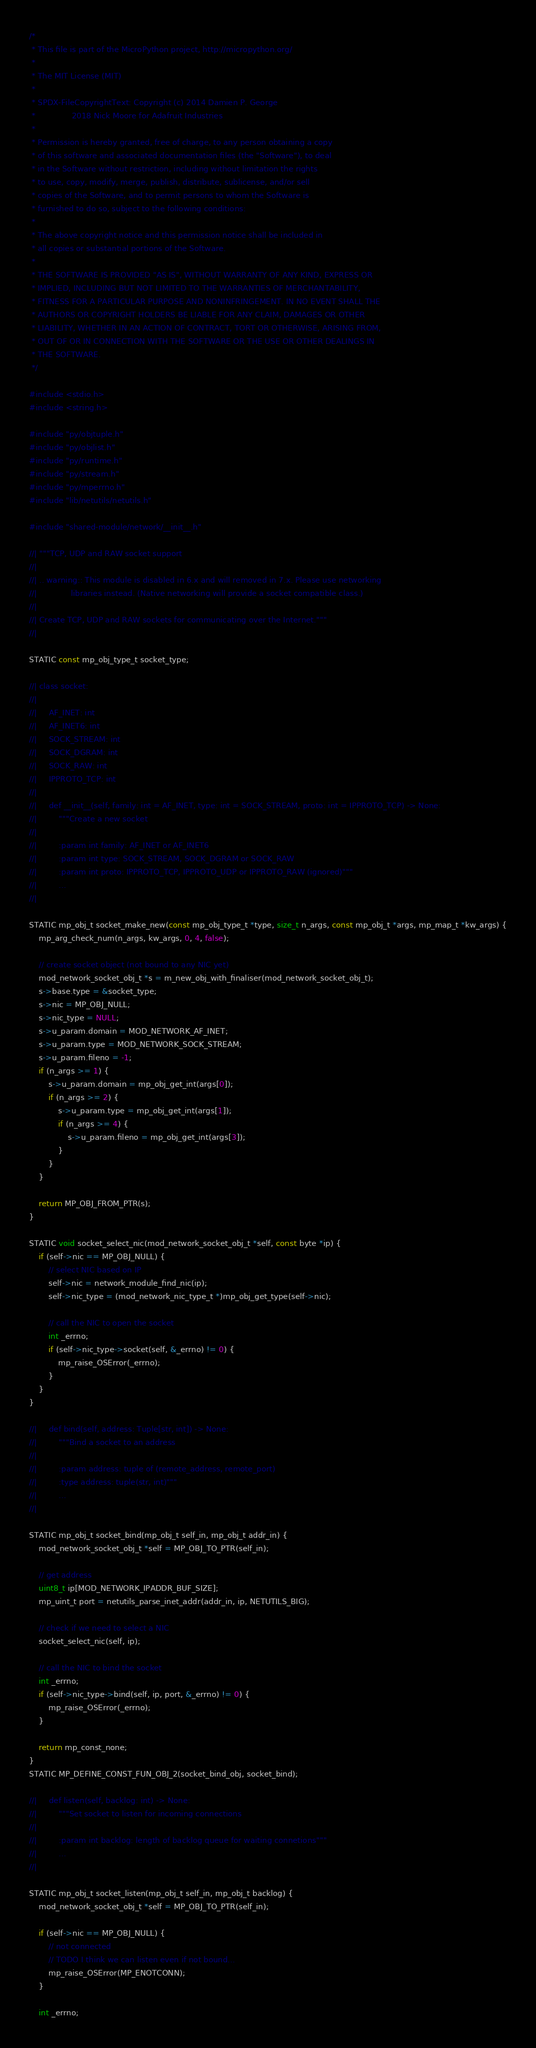Convert code to text. <code><loc_0><loc_0><loc_500><loc_500><_C_>/*
 * This file is part of the MicroPython project, http://micropython.org/
 *
 * The MIT License (MIT)
 *
 * SPDX-FileCopyrightText: Copyright (c) 2014 Damien P. George
 *               2018 Nick Moore for Adafruit Industries
 *
 * Permission is hereby granted, free of charge, to any person obtaining a copy
 * of this software and associated documentation files (the "Software"), to deal
 * in the Software without restriction, including without limitation the rights
 * to use, copy, modify, merge, publish, distribute, sublicense, and/or sell
 * copies of the Software, and to permit persons to whom the Software is
 * furnished to do so, subject to the following conditions:
 *
 * The above copyright notice and this permission notice shall be included in
 * all copies or substantial portions of the Software.
 *
 * THE SOFTWARE IS PROVIDED "AS IS", WITHOUT WARRANTY OF ANY KIND, EXPRESS OR
 * IMPLIED, INCLUDING BUT NOT LIMITED TO THE WARRANTIES OF MERCHANTABILITY,
 * FITNESS FOR A PARTICULAR PURPOSE AND NONINFRINGEMENT. IN NO EVENT SHALL THE
 * AUTHORS OR COPYRIGHT HOLDERS BE LIABLE FOR ANY CLAIM, DAMAGES OR OTHER
 * LIABILITY, WHETHER IN AN ACTION OF CONTRACT, TORT OR OTHERWISE, ARISING FROM,
 * OUT OF OR IN CONNECTION WITH THE SOFTWARE OR THE USE OR OTHER DEALINGS IN
 * THE SOFTWARE.
 */

#include <stdio.h>
#include <string.h>

#include "py/objtuple.h"
#include "py/objlist.h"
#include "py/runtime.h"
#include "py/stream.h"
#include "py/mperrno.h"
#include "lib/netutils/netutils.h"

#include "shared-module/network/__init__.h"

//| """TCP, UDP and RAW socket support
//|
//| .. warning:: This module is disabled in 6.x and will removed in 7.x. Please use networking
//|              libraries instead. (Native networking will provide a socket compatible class.)
//|
//| Create TCP, UDP and RAW sockets for communicating over the Internet."""
//|

STATIC const mp_obj_type_t socket_type;

//| class socket:
//|
//|     AF_INET: int
//|     AF_INET6: int
//|     SOCK_STREAM: int
//|     SOCK_DGRAM: int
//|     SOCK_RAW: int
//|     IPPROTO_TCP: int
//|
//|     def __init__(self, family: int = AF_INET, type: int = SOCK_STREAM, proto: int = IPPROTO_TCP) -> None:
//|         """Create a new socket
//|
//|         :param int family: AF_INET or AF_INET6
//|         :param int type: SOCK_STREAM, SOCK_DGRAM or SOCK_RAW
//|         :param int proto: IPPROTO_TCP, IPPROTO_UDP or IPPROTO_RAW (ignored)"""
//|         ...
//|

STATIC mp_obj_t socket_make_new(const mp_obj_type_t *type, size_t n_args, const mp_obj_t *args, mp_map_t *kw_args) {
    mp_arg_check_num(n_args, kw_args, 0, 4, false);

    // create socket object (not bound to any NIC yet)
    mod_network_socket_obj_t *s = m_new_obj_with_finaliser(mod_network_socket_obj_t);
    s->base.type = &socket_type;
    s->nic = MP_OBJ_NULL;
    s->nic_type = NULL;
    s->u_param.domain = MOD_NETWORK_AF_INET;
    s->u_param.type = MOD_NETWORK_SOCK_STREAM;
    s->u_param.fileno = -1;
    if (n_args >= 1) {
        s->u_param.domain = mp_obj_get_int(args[0]);
        if (n_args >= 2) {
            s->u_param.type = mp_obj_get_int(args[1]);
            if (n_args >= 4) {
                s->u_param.fileno = mp_obj_get_int(args[3]);
            }
        }
    }

    return MP_OBJ_FROM_PTR(s);
}

STATIC void socket_select_nic(mod_network_socket_obj_t *self, const byte *ip) {
    if (self->nic == MP_OBJ_NULL) {
        // select NIC based on IP
        self->nic = network_module_find_nic(ip);
        self->nic_type = (mod_network_nic_type_t *)mp_obj_get_type(self->nic);

        // call the NIC to open the socket
        int _errno;
        if (self->nic_type->socket(self, &_errno) != 0) {
            mp_raise_OSError(_errno);
        }
    }
}

//|     def bind(self, address: Tuple[str, int]) -> None:
//|         """Bind a socket to an address
//|
//|         :param address: tuple of (remote_address, remote_port)
//|         :type address: tuple(str, int)"""
//|         ...
//|

STATIC mp_obj_t socket_bind(mp_obj_t self_in, mp_obj_t addr_in) {
    mod_network_socket_obj_t *self = MP_OBJ_TO_PTR(self_in);

    // get address
    uint8_t ip[MOD_NETWORK_IPADDR_BUF_SIZE];
    mp_uint_t port = netutils_parse_inet_addr(addr_in, ip, NETUTILS_BIG);

    // check if we need to select a NIC
    socket_select_nic(self, ip);

    // call the NIC to bind the socket
    int _errno;
    if (self->nic_type->bind(self, ip, port, &_errno) != 0) {
        mp_raise_OSError(_errno);
    }

    return mp_const_none;
}
STATIC MP_DEFINE_CONST_FUN_OBJ_2(socket_bind_obj, socket_bind);

//|     def listen(self, backlog: int) -> None:
//|         """Set socket to listen for incoming connections
//|
//|         :param int backlog: length of backlog queue for waiting connetions"""
//|         ...
//|

STATIC mp_obj_t socket_listen(mp_obj_t self_in, mp_obj_t backlog) {
    mod_network_socket_obj_t *self = MP_OBJ_TO_PTR(self_in);

    if (self->nic == MP_OBJ_NULL) {
        // not connected
        // TODO I think we can listen even if not bound...
        mp_raise_OSError(MP_ENOTCONN);
    }

    int _errno;</code> 